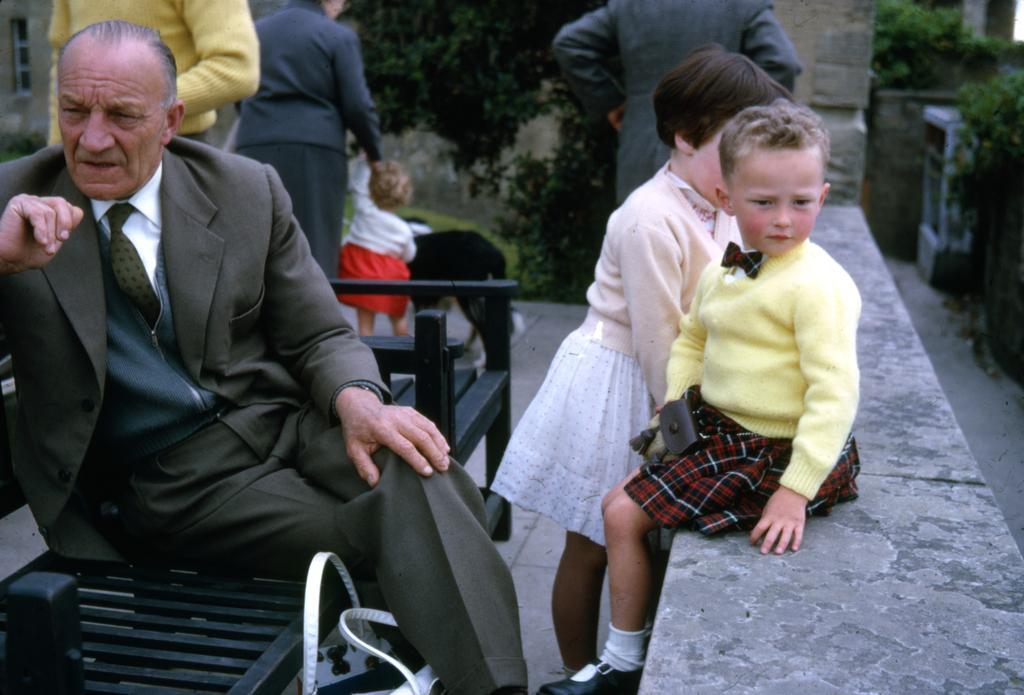Could you give a brief overview of what you see in this image? In front of the picture, we see the old man is sitting on the bench. Beside him, we see a white bag and a girl is standing. Beside her, we see a girl is sitting on the wall. On the right side, we see the trees. On the left side, we see a man, woman and a child are standing. There are trees and the buildings in the background. 